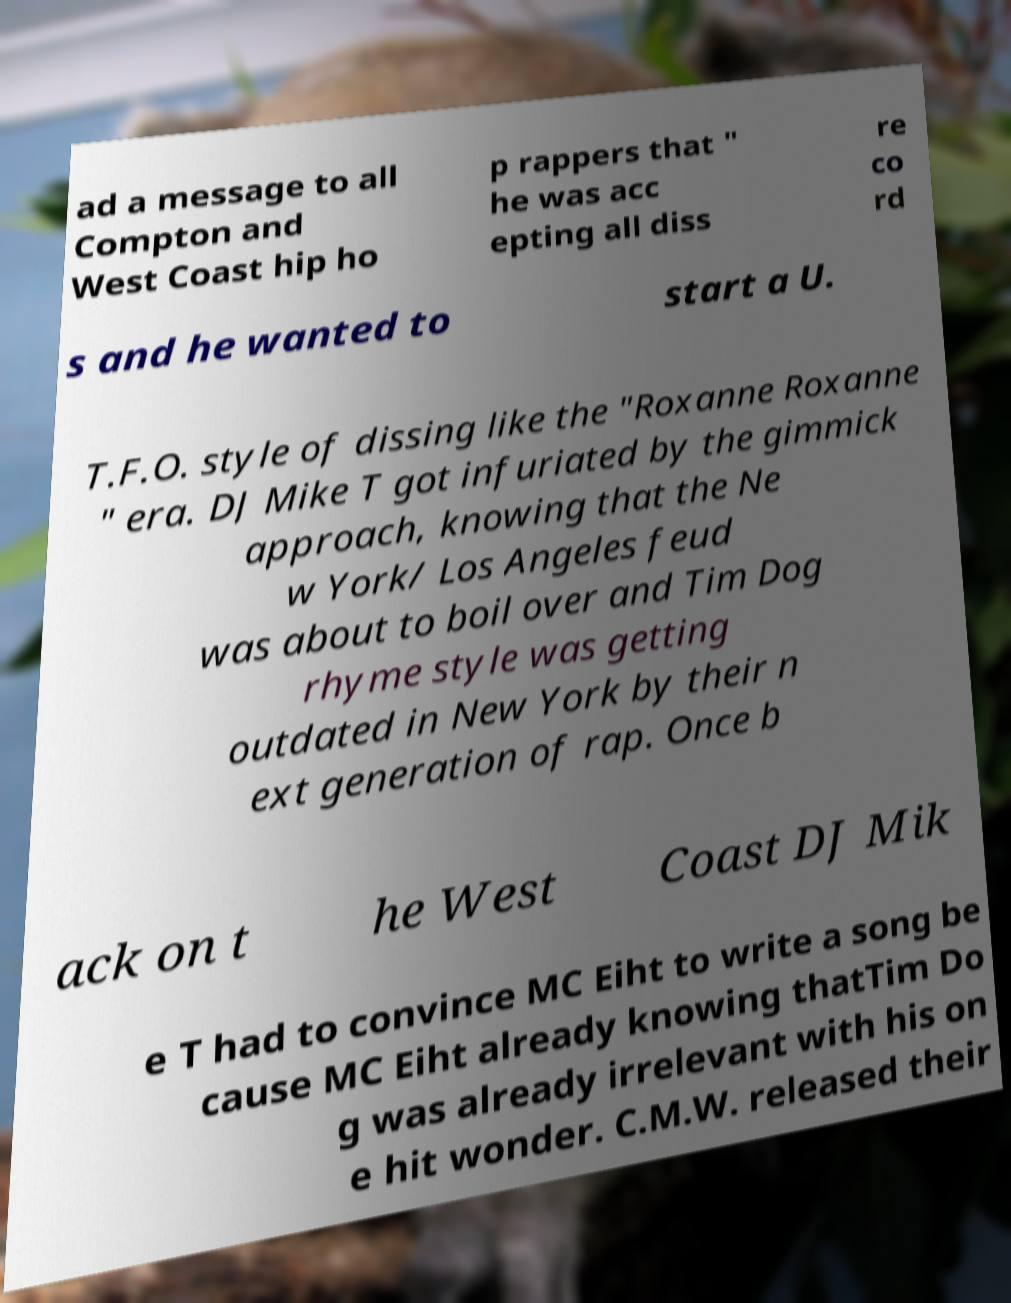Please read and relay the text visible in this image. What does it say? ad a message to all Compton and West Coast hip ho p rappers that " he was acc epting all diss re co rd s and he wanted to start a U. T.F.O. style of dissing like the "Roxanne Roxanne " era. DJ Mike T got infuriated by the gimmick approach, knowing that the Ne w York/ Los Angeles feud was about to boil over and Tim Dog rhyme style was getting outdated in New York by their n ext generation of rap. Once b ack on t he West Coast DJ Mik e T had to convince MC Eiht to write a song be cause MC Eiht already knowing thatTim Do g was already irrelevant with his on e hit wonder. C.M.W. released their 